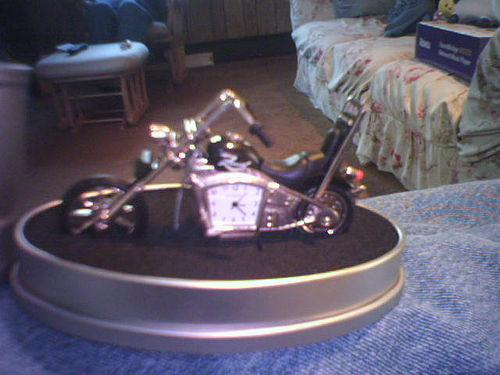What best describes the size of the motorcycle?

Choices:
A) 12 feet
B) 10 feet
C) miniature
D) 30 inches miniature 